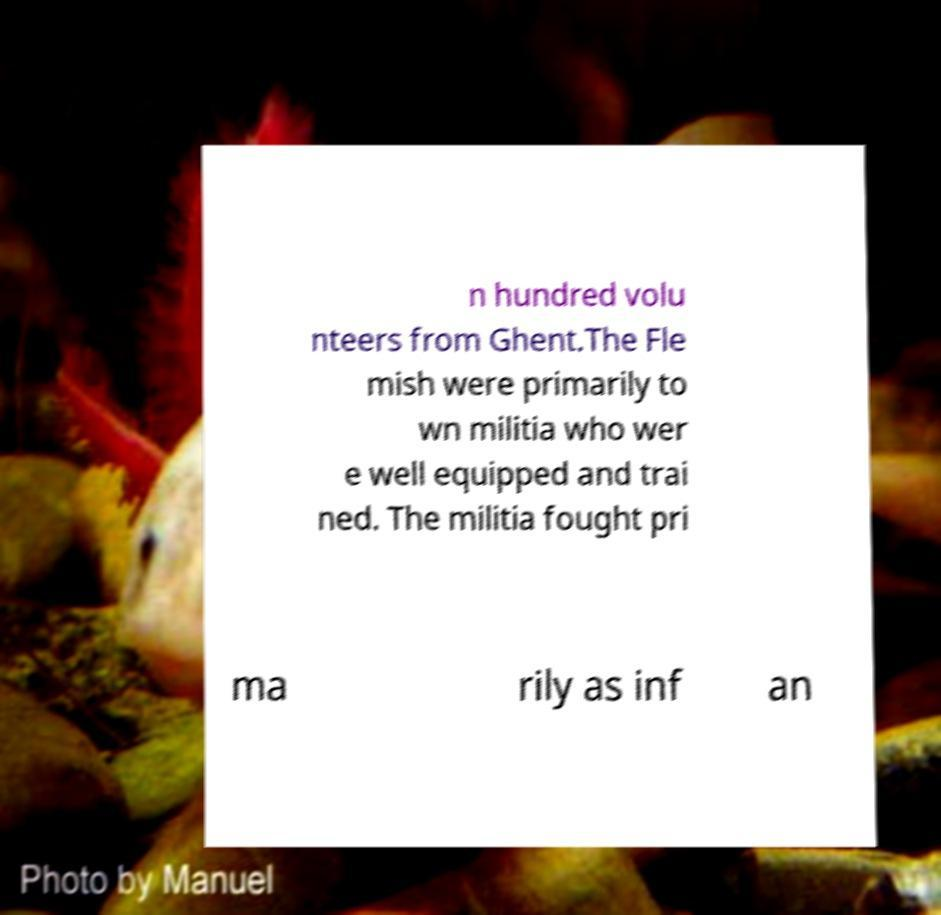I need the written content from this picture converted into text. Can you do that? n hundred volu nteers from Ghent.The Fle mish were primarily to wn militia who wer e well equipped and trai ned. The militia fought pri ma rily as inf an 